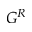<formula> <loc_0><loc_0><loc_500><loc_500>G ^ { R }</formula> 